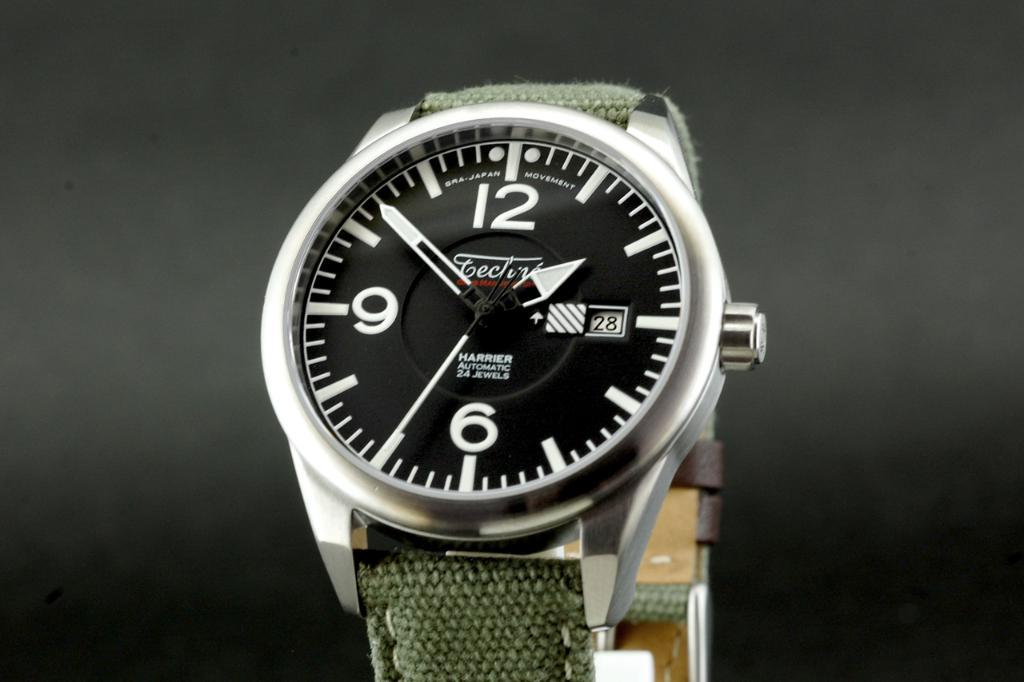Provide a one-sentence caption for the provided image. A Harrier watch is displayed over a dark background. 